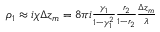<formula> <loc_0><loc_0><loc_500><loc_500>\begin{array} { r } { \rho _ { 1 } \approx i \chi \Delta z _ { m } = 8 \pi i \frac { \gamma _ { 1 } } { 1 - \gamma _ { 1 } ^ { 2 } } \frac { r _ { 2 } } { 1 - r _ { 2 } } \frac { \Delta z _ { m } } { \lambda } } \end{array}</formula> 